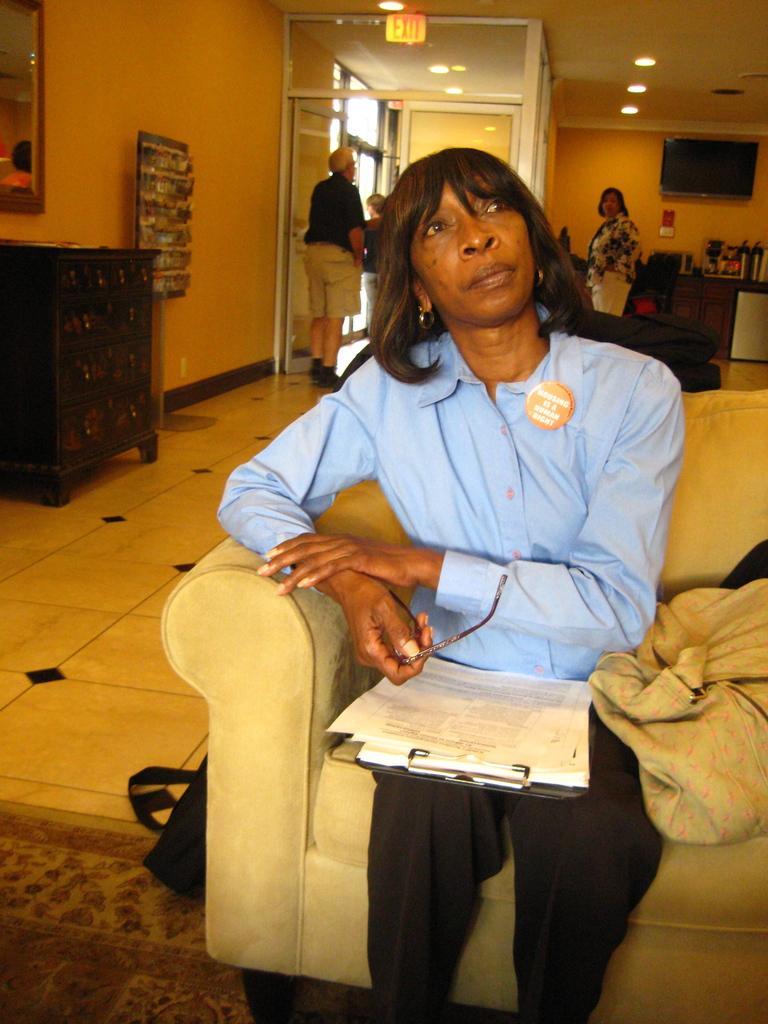Describe this image in one or two sentences. In this image I can see the person sitting on the couch and holding the specs. I can see the pad with papers on her. To the side there are some clothes and the bag on the floor. To the left I can see the cupboard and the mirror to the wall. In the background I can see the group of people, some objects and the television to the wall. I can see some lights and the exit board in the top. 